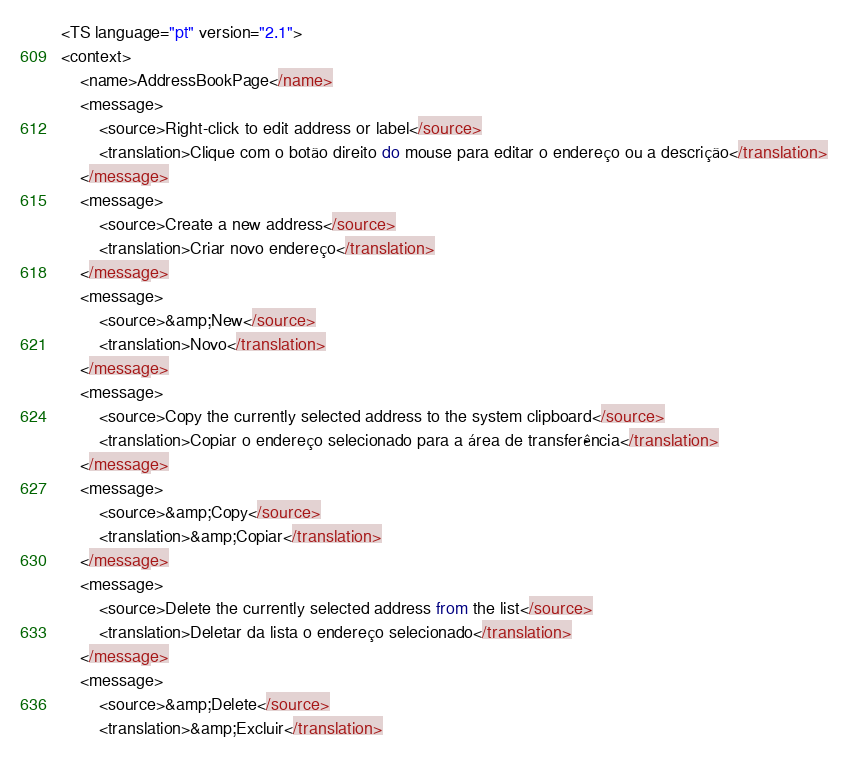Convert code to text. <code><loc_0><loc_0><loc_500><loc_500><_TypeScript_><TS language="pt" version="2.1">
<context>
    <name>AddressBookPage</name>
    <message>
        <source>Right-click to edit address or label</source>
        <translation>Clique com o botão direito do mouse para editar o endereço ou a descrição</translation>
    </message>
    <message>
        <source>Create a new address</source>
        <translation>Criar novo endereço</translation>
    </message>
    <message>
        <source>&amp;New</source>
        <translation>Novo</translation>
    </message>
    <message>
        <source>Copy the currently selected address to the system clipboard</source>
        <translation>Copiar o endereço selecionado para a área de transferência</translation>
    </message>
    <message>
        <source>&amp;Copy</source>
        <translation>&amp;Copiar</translation>
    </message>
    <message>
        <source>Delete the currently selected address from the list</source>
        <translation>Deletar da lista o endereço selecionado</translation>
    </message>
    <message>
        <source>&amp;Delete</source>
        <translation>&amp;Excluir</translation></code> 